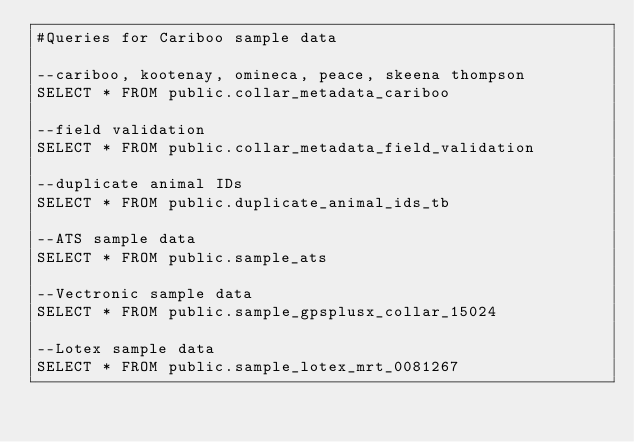Convert code to text. <code><loc_0><loc_0><loc_500><loc_500><_SQL_>#Queries for Cariboo sample data

--cariboo, kootenay, omineca, peace, skeena thompson
SELECT * FROM public.collar_metadata_cariboo

--field validation
SELECT * FROM public.collar_metadata_field_validation

--duplicate animal IDs
SELECT * FROM public.duplicate_animal_ids_tb

--ATS sample data
SELECT * FROM public.sample_ats

--Vectronic sample data
SELECT * FROM public.sample_gpsplusx_collar_15024

--Lotex sample data
SELECT * FROM public.sample_lotex_mrt_0081267</code> 